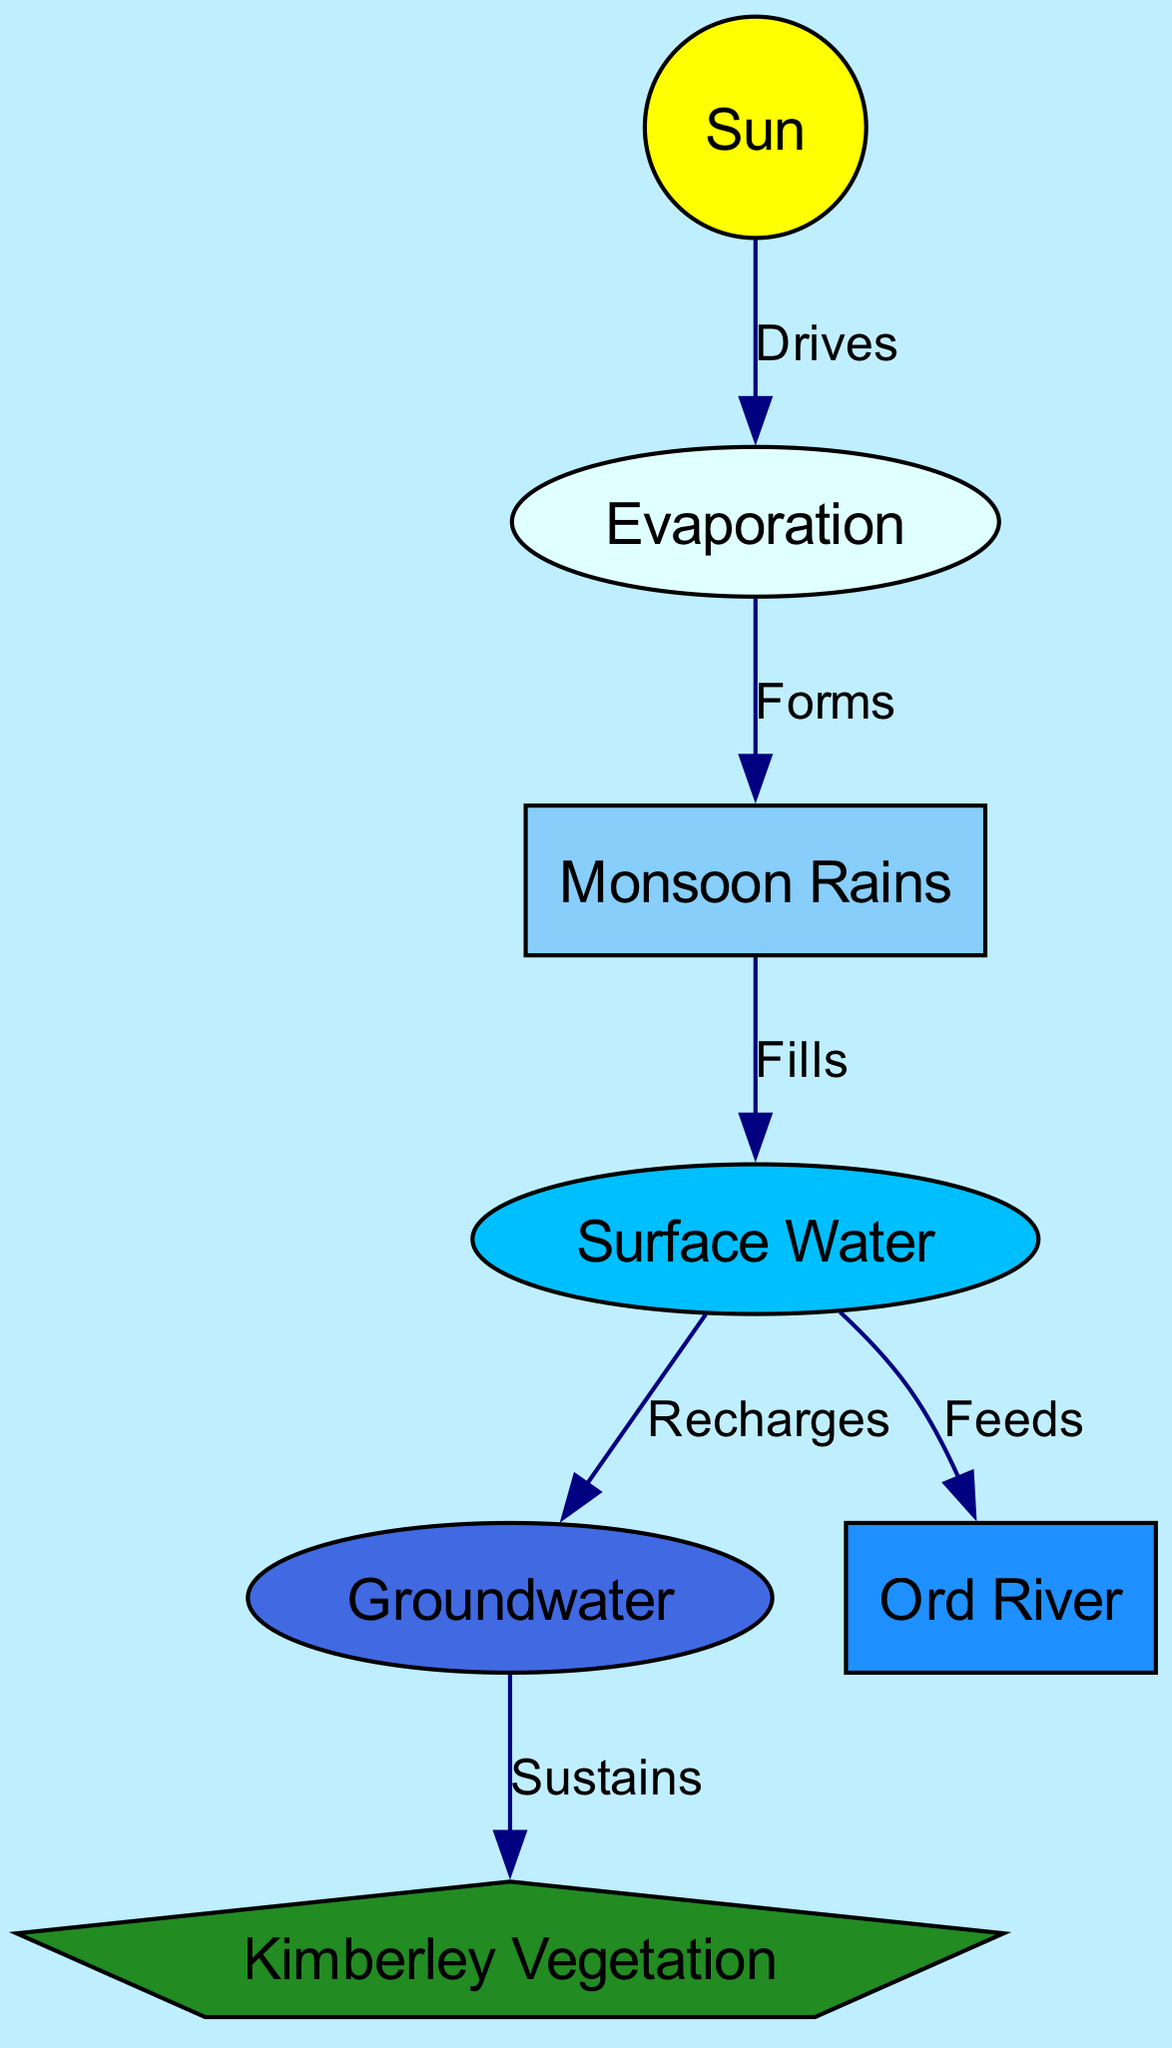What drives evaporation in the Kimberley region? The diagram shows an arrow from the Sun node to the Evaporation node labeled "Drives." This indicates that the Sun is the source of energy that causes evaporation.
Answer: Sun How many total nodes are in the diagram? By counting all the nodes listed in the initial data, there are 7 nodes: Sun, Monsoon Rains, Evaporation, Surface Water, Groundwater, Kimberley Vegetation, and Ord River.
Answer: 7 What do monsoon rains fill? The diagram has an arrow labeled "Fills" pointing from the Monsoon Rains node to the Surface Water node, indicating that the monsoon rains contribute to filling the surface water.
Answer: Surface Water What does surface water recharge? The diagram shows an edge labeled "Recharges" from Surface Water to Groundwater, which means that surface water replenishes or recharges groundwater supplies.
Answer: Groundwater What sustains vegetation in the Kimberley area? There is an edge labeled "Sustains" going from Groundwater to Vegetation, which indicates that groundwater is the resource that sustains the vegetation in the Kimberley region.
Answer: Groundwater How does evaporation relate to monsoon formation? According to the diagram, there’s an edge from Evaporation to Monsoon Rains, labeled "Forms," which means that evaporation plays a role in the formation of monsoon rains.
Answer: Forms What does surface water feed into? An arrow labeled "Feeds" leads from Surface Water to the Ord River, indicating that surface water provides resources to the Ord River.
Answer: Ord River 